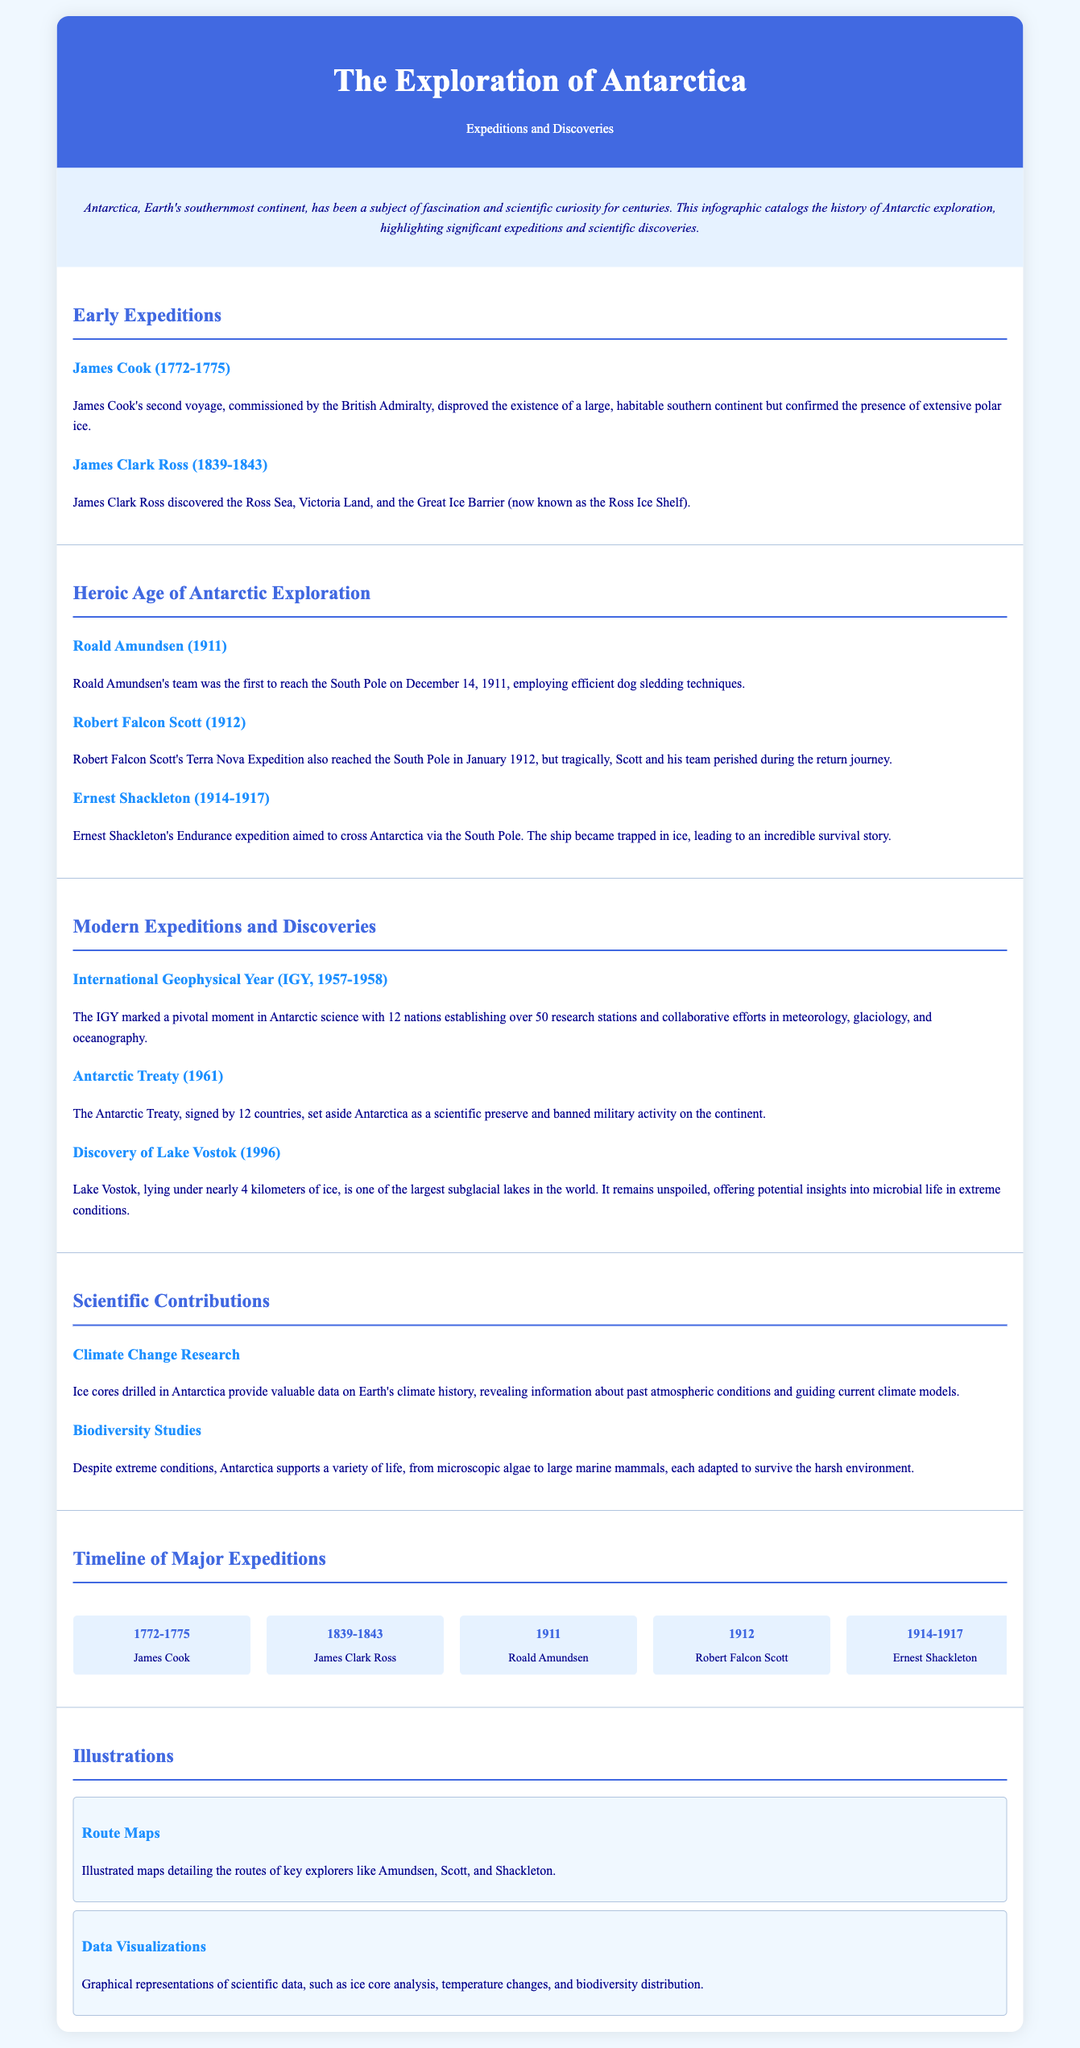what year did Roald Amundsen reach the South Pole? The document states that Amundsen's team was the first to reach the South Pole on December 14, 1911.
Answer: 1911 who discovered the Ross Ice Shelf? According to the infographic, James Clark Ross is credited with discovering the Ross Ice Shelf during his expedition.
Answer: James Clark Ross what significant event took place during the International Geophysical Year? The document notes that the IGY, held from 1957 to 1958, involved 12 nations establishing over 50 research stations for joint scientific efforts.
Answer: 12 nations establishing over 50 research stations what was the fate of Robert Falcon Scott's team? It is indicated in the document that Scott and his team perished during their return journey from the South Pole.
Answer: Perished what major scientific discovery was made in 1996? The document highlights the discovery of Lake Vostok as a significant scientific achievement in 1996.
Answer: Lake Vostok how many years did Shackleton's expedition last? The timeline indicates that Ernest Shackleton's Endurance expedition lasted from 1914 to 1917, which is three years.
Answer: 3 years what does the Antarctic Treaty establish? The document specifies that the Antarctic Treaty set aside Antarctica as a scientific preserve and banned military activity.
Answer: Scientific preserve which explorer's route is illustrated in the infographic? The document mentions route maps for explorers like Amundsen, Scott, and Shackleton, indicating their paths taken in Antarctica.
Answer: Amundsen, Scott, Shackleton 